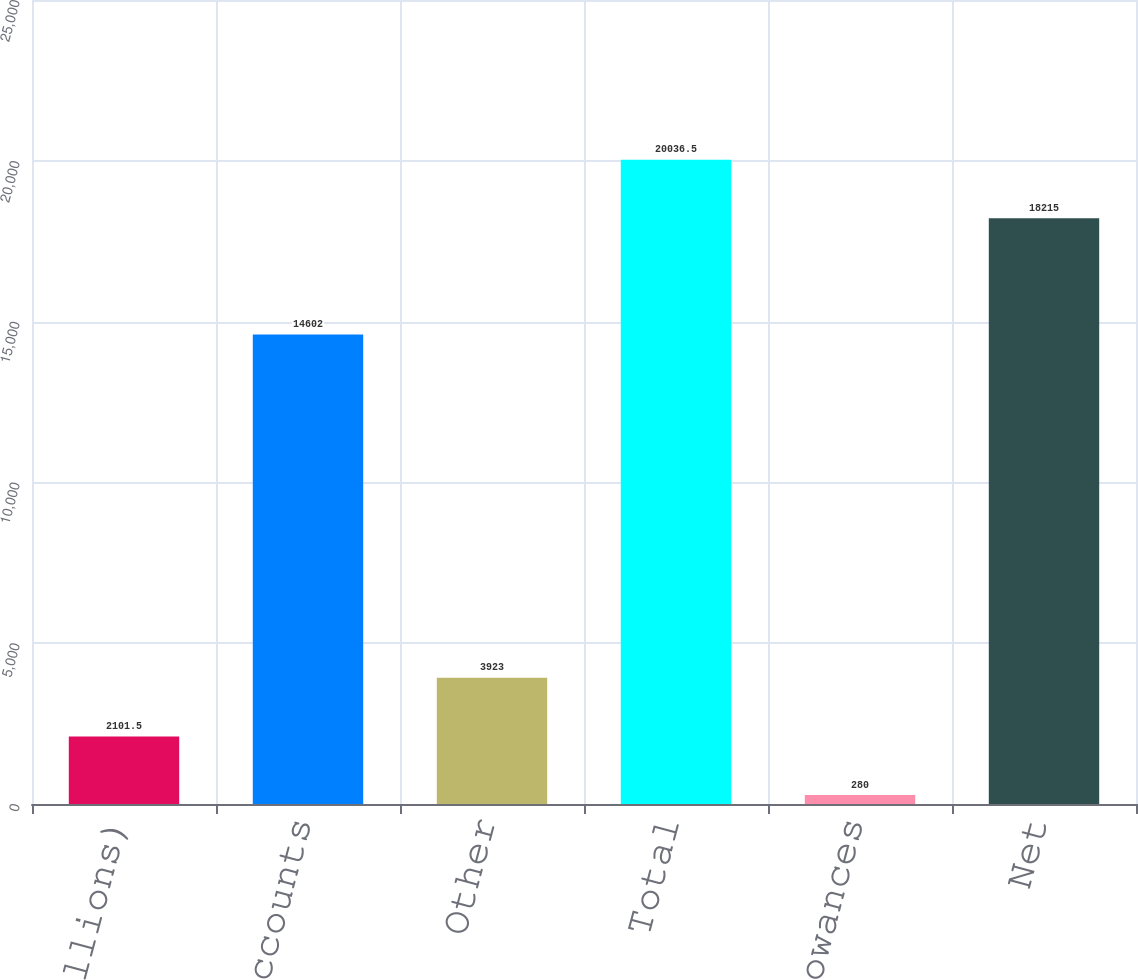Convert chart. <chart><loc_0><loc_0><loc_500><loc_500><bar_chart><fcel>(In millions)<fcel>Customer accounts<fcel>Other<fcel>Total<fcel>Allowances<fcel>Net<nl><fcel>2101.5<fcel>14602<fcel>3923<fcel>20036.5<fcel>280<fcel>18215<nl></chart> 